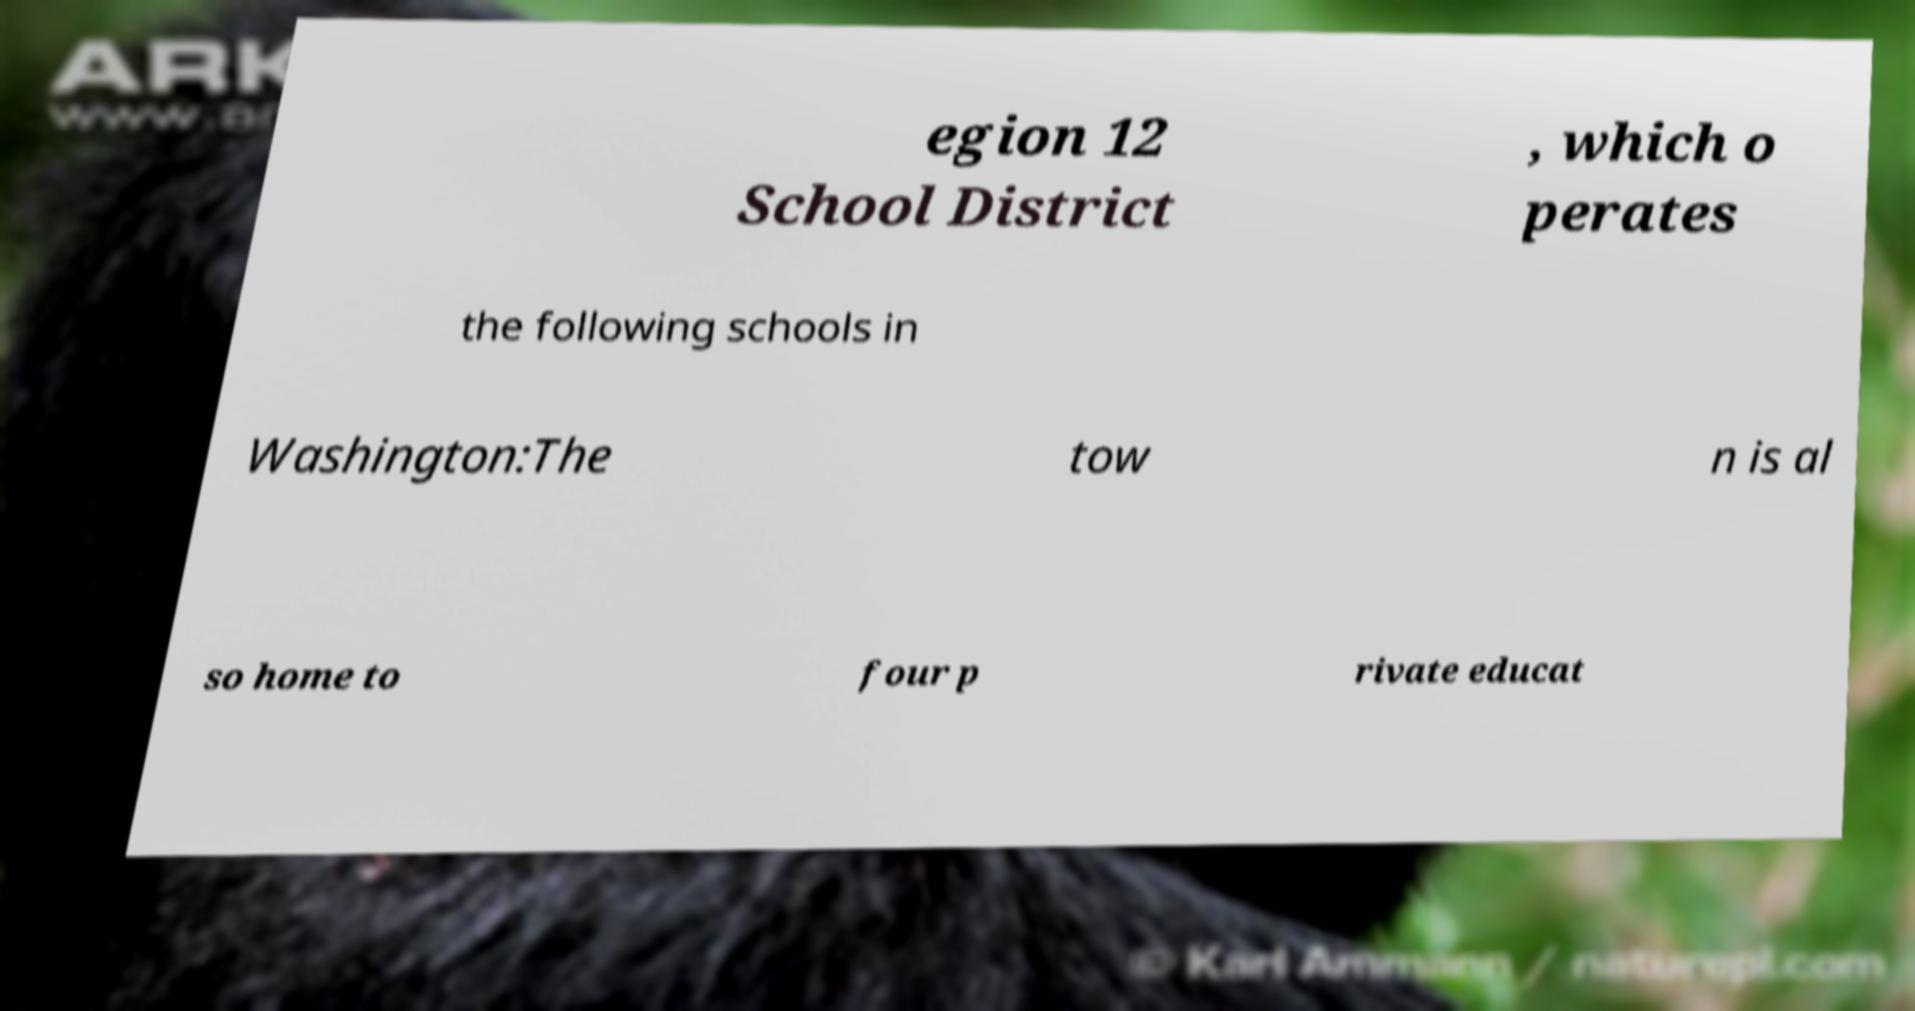Can you accurately transcribe the text from the provided image for me? egion 12 School District , which o perates the following schools in Washington:The tow n is al so home to four p rivate educat 